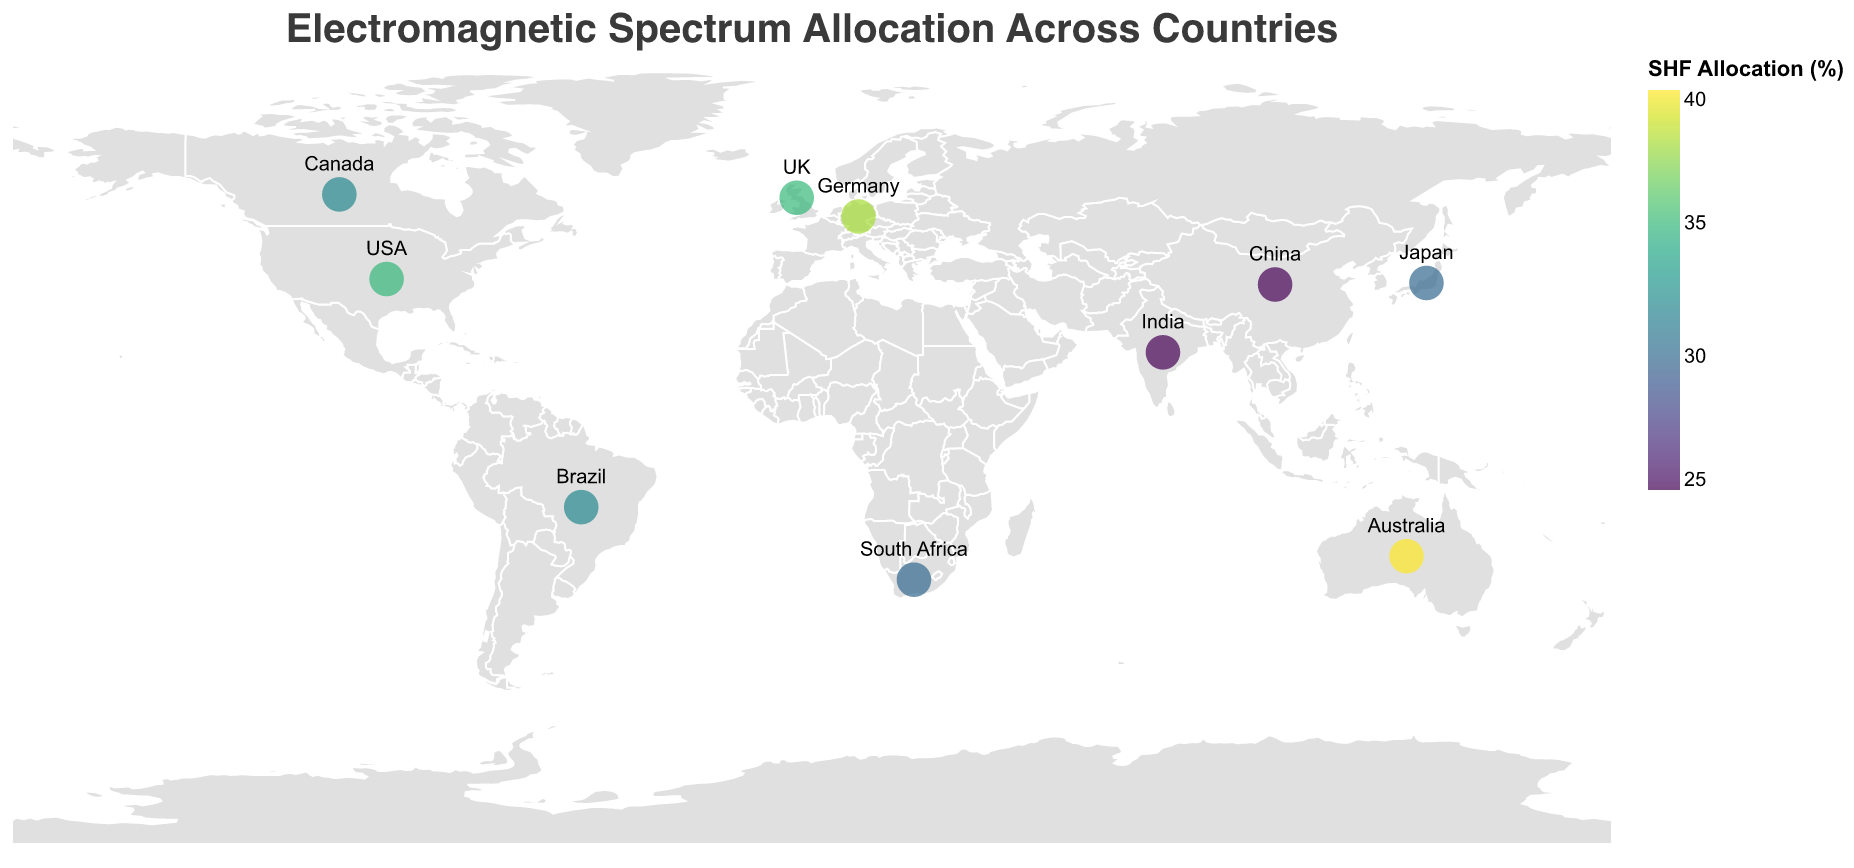What is the primary usage of the electromagnetic spectrum in Japan? By looking at the tooltip associated with Japan, we can see "Primary Usage" is listed as "Telecommunications".
Answer: Telecommunications Which country allocates the highest percentage of the spectrum to VHF? From the tooltip data, India allocates the highest percentage with 35% for VHF.
Answer: India Compare the SHF allocation percentages between Germany and Brazil. Which country allocates more? Germany allocates 38% and Brazil allocates 32% to SHF, so Germany allocates more.
Answer: Germany What regions have countries with a primary usage related to military or defense? USA (Commercial/Military, North America) and UK (Defense/Scientific, Europe) are two countries listed with primary usage related to military or defense.
Answer: North America, Europe How does Canada's VHF allocation compare to Australia's? Canada's VHF allocation is 23% while Australia's is 18%. Canada allocates 5% more to VHF.
Answer: Canada allocates 5% more Which country in Asia utilizes the electromagnetic spectrum most for Telecommunication? From the data, Japan in Asia lists "Telecommunications" as the primary usage.
Answer: Japan Identify the country with the maximum EHF allocation and describe its primary usage. Both Japan and Brazil have the maximum EHF allocation of 15%. Japan's primary usage is Telecommunications, and Brazil's is Public Safety/IoT.
Answer: Japan: Telecommunications, Brazil: Public Safety/IoT What is the average UHF allocation percentage across all listed countries? Sum all UHF Allocation (%) values: (30+35+28+32+25+28+30+33+30+35)=306, then divide by the number of countries (10). 306/10 = 30.6%
Answer: 30.6% Between Africa and Oceania, which region dedicates more of its spectrum to SHF and by how much? South Africa (Africa) has 30% SHF allocation, while Australia (Oceania) has 40% SHF allocation. Oceania dedicates 10% more.
Answer: Oceania, 10% more What is the common secondary usage category among countries with high SHF allocation? Germany (38%) Broadcasting/Research, Australia (40%) Weather/Satellite, UK (35%) Defense/Scientific – Secondary categories like Research, Scientific, and Satellite are common.
Answer: Research, Scientific, Satellite 